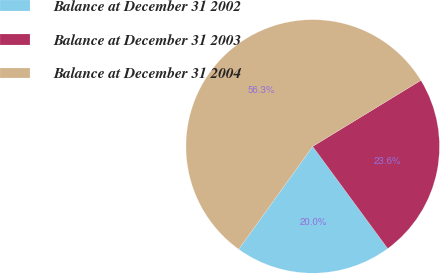Convert chart to OTSL. <chart><loc_0><loc_0><loc_500><loc_500><pie_chart><fcel>Balance at December 31 2002<fcel>Balance at December 31 2003<fcel>Balance at December 31 2004<nl><fcel>20.01%<fcel>23.64%<fcel>56.35%<nl></chart> 